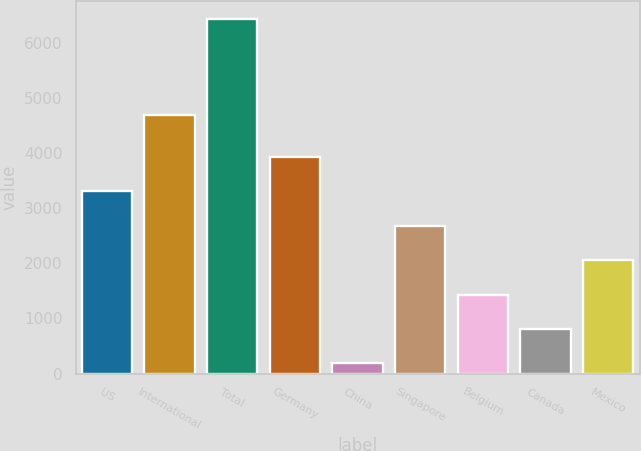Convert chart to OTSL. <chart><loc_0><loc_0><loc_500><loc_500><bar_chart><fcel>US<fcel>International<fcel>Total<fcel>Germany<fcel>China<fcel>Singapore<fcel>Belgium<fcel>Canada<fcel>Mexico<nl><fcel>3313<fcel>4690<fcel>6444<fcel>3939.2<fcel>182<fcel>2686.8<fcel>1434.4<fcel>808.2<fcel>2060.6<nl></chart> 